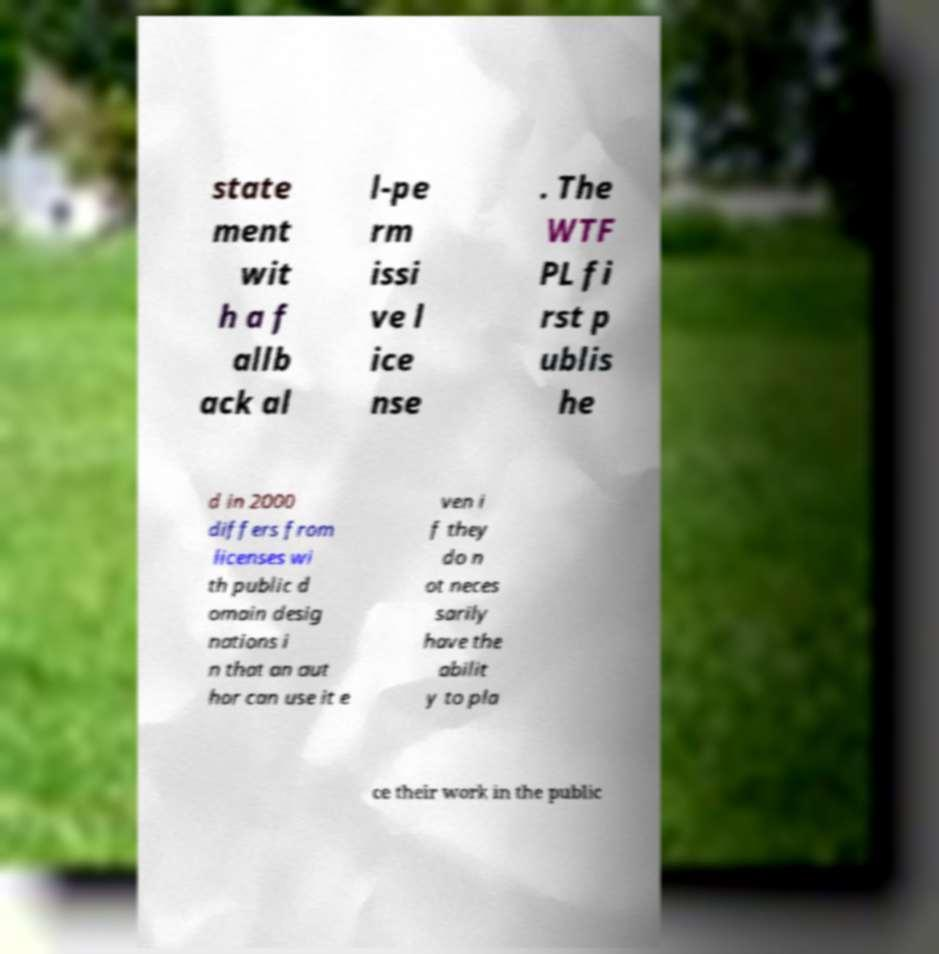Could you assist in decoding the text presented in this image and type it out clearly? state ment wit h a f allb ack al l-pe rm issi ve l ice nse . The WTF PL fi rst p ublis he d in 2000 differs from licenses wi th public d omain desig nations i n that an aut hor can use it e ven i f they do n ot neces sarily have the abilit y to pla ce their work in the public 